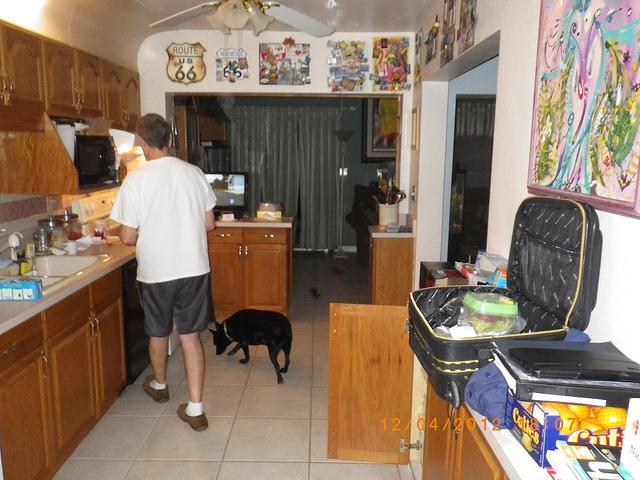What is hanging from the ceiling?
Give a very brief answer. Fan. Is it still daytime?
Write a very short answer. No. What is the dog doing?
Keep it brief. Walking. What color are the mans socks?
Give a very brief answer. White. 